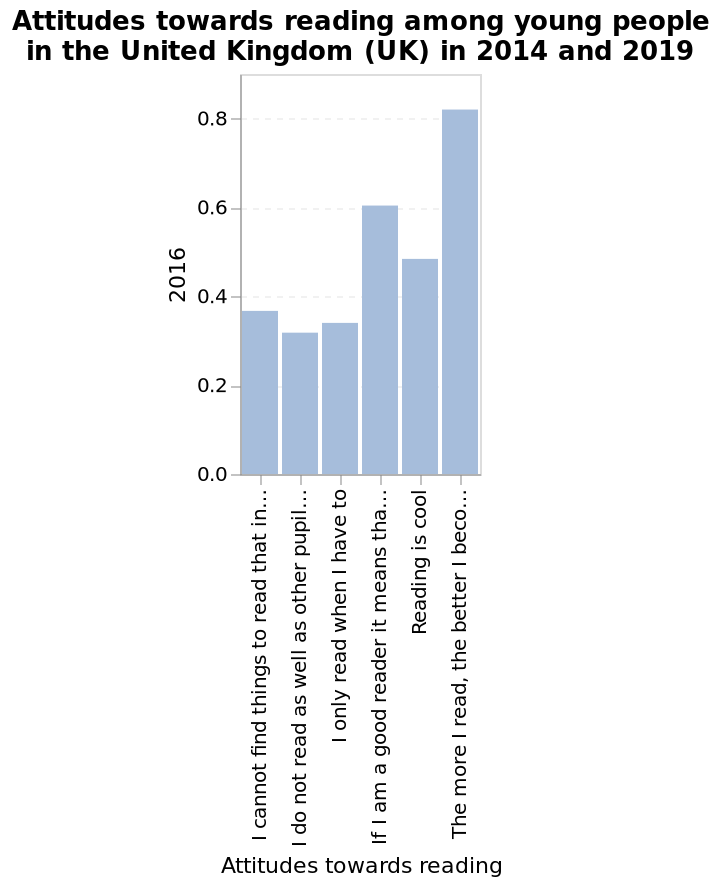<image>
What was the general opinion of most pupils regarding reading?  Most pupils felt that the more reading they do, the better they will become. please summary the statistics and relations of the chart Most pupils felt that the more reading they do, the better they will become. The least amount of pupils felt that they do not read as well as other pupils. Do most pupils feel that the less reading they do, the better they will become? No. Most pupils felt that the more reading they do, the better they will become. 